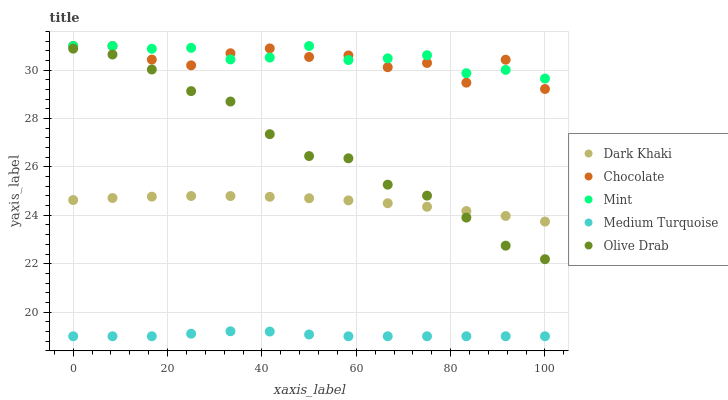Does Medium Turquoise have the minimum area under the curve?
Answer yes or no. Yes. Does Mint have the maximum area under the curve?
Answer yes or no. Yes. Does Olive Drab have the minimum area under the curve?
Answer yes or no. No. Does Olive Drab have the maximum area under the curve?
Answer yes or no. No. Is Dark Khaki the smoothest?
Answer yes or no. Yes. Is Chocolate the roughest?
Answer yes or no. Yes. Is Mint the smoothest?
Answer yes or no. No. Is Mint the roughest?
Answer yes or no. No. Does Medium Turquoise have the lowest value?
Answer yes or no. Yes. Does Olive Drab have the lowest value?
Answer yes or no. No. Does Chocolate have the highest value?
Answer yes or no. Yes. Does Olive Drab have the highest value?
Answer yes or no. No. Is Medium Turquoise less than Dark Khaki?
Answer yes or no. Yes. Is Mint greater than Olive Drab?
Answer yes or no. Yes. Does Mint intersect Chocolate?
Answer yes or no. Yes. Is Mint less than Chocolate?
Answer yes or no. No. Is Mint greater than Chocolate?
Answer yes or no. No. Does Medium Turquoise intersect Dark Khaki?
Answer yes or no. No. 